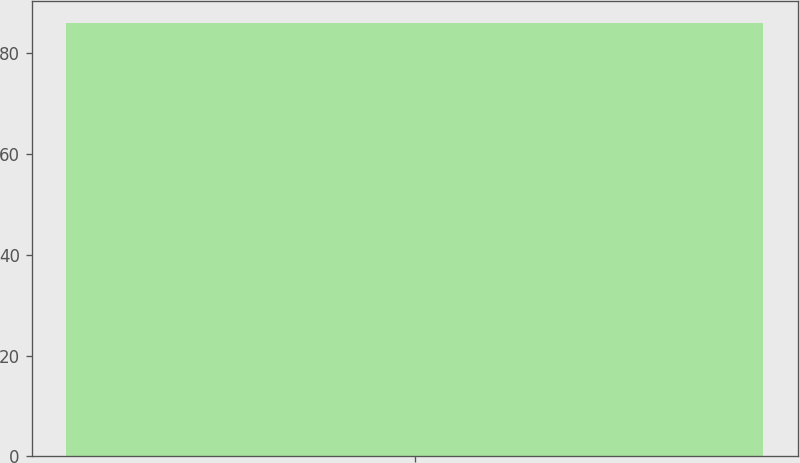Convert chart to OTSL. <chart><loc_0><loc_0><loc_500><loc_500><bar_chart><ecel><nl><fcel>86<nl></chart> 